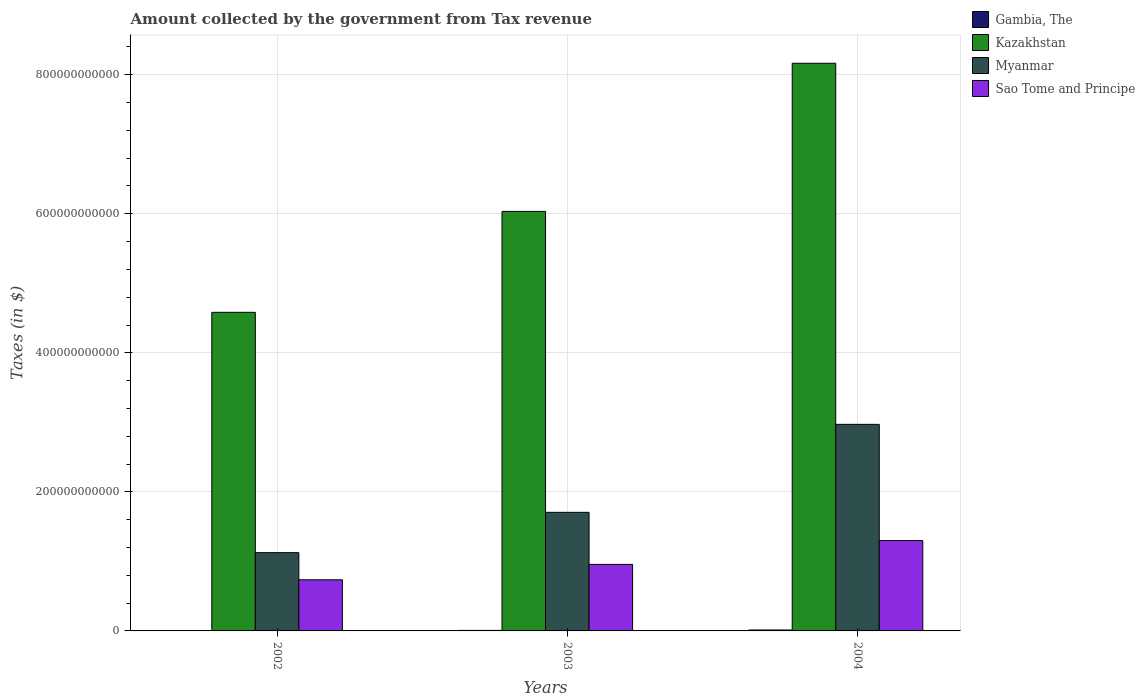How many different coloured bars are there?
Ensure brevity in your answer.  4. Are the number of bars per tick equal to the number of legend labels?
Provide a succinct answer. Yes. In how many cases, is the number of bars for a given year not equal to the number of legend labels?
Provide a short and direct response. 0. What is the amount collected by the government from tax revenue in Myanmar in 2003?
Make the answer very short. 1.71e+11. Across all years, what is the maximum amount collected by the government from tax revenue in Myanmar?
Keep it short and to the point. 2.97e+11. Across all years, what is the minimum amount collected by the government from tax revenue in Kazakhstan?
Make the answer very short. 4.58e+11. In which year was the amount collected by the government from tax revenue in Kazakhstan maximum?
Give a very brief answer. 2004. What is the total amount collected by the government from tax revenue in Gambia, The in the graph?
Your answer should be compact. 2.70e+09. What is the difference between the amount collected by the government from tax revenue in Kazakhstan in 2002 and that in 2003?
Your answer should be compact. -1.45e+11. What is the difference between the amount collected by the government from tax revenue in Kazakhstan in 2002 and the amount collected by the government from tax revenue in Gambia, The in 2004?
Keep it short and to the point. 4.57e+11. What is the average amount collected by the government from tax revenue in Sao Tome and Principe per year?
Your answer should be compact. 9.97e+1. In the year 2004, what is the difference between the amount collected by the government from tax revenue in Myanmar and amount collected by the government from tax revenue in Kazakhstan?
Your answer should be very brief. -5.19e+11. What is the ratio of the amount collected by the government from tax revenue in Gambia, The in 2002 to that in 2004?
Your answer should be compact. 0.41. Is the difference between the amount collected by the government from tax revenue in Myanmar in 2002 and 2003 greater than the difference between the amount collected by the government from tax revenue in Kazakhstan in 2002 and 2003?
Keep it short and to the point. Yes. What is the difference between the highest and the second highest amount collected by the government from tax revenue in Myanmar?
Your answer should be compact. 1.27e+11. What is the difference between the highest and the lowest amount collected by the government from tax revenue in Kazakhstan?
Offer a terse response. 3.58e+11. What does the 1st bar from the left in 2002 represents?
Your answer should be compact. Gambia, The. What does the 3rd bar from the right in 2002 represents?
Your answer should be compact. Kazakhstan. How many years are there in the graph?
Give a very brief answer. 3. What is the difference between two consecutive major ticks on the Y-axis?
Your response must be concise. 2.00e+11. Are the values on the major ticks of Y-axis written in scientific E-notation?
Ensure brevity in your answer.  No. Does the graph contain any zero values?
Give a very brief answer. No. How are the legend labels stacked?
Your response must be concise. Vertical. What is the title of the graph?
Offer a very short reply. Amount collected by the government from Tax revenue. What is the label or title of the Y-axis?
Make the answer very short. Taxes (in $). What is the Taxes (in $) of Gambia, The in 2002?
Keep it short and to the point. 5.61e+08. What is the Taxes (in $) in Kazakhstan in 2002?
Offer a terse response. 4.58e+11. What is the Taxes (in $) of Myanmar in 2002?
Offer a very short reply. 1.13e+11. What is the Taxes (in $) of Sao Tome and Principe in 2002?
Ensure brevity in your answer.  7.35e+1. What is the Taxes (in $) in Gambia, The in 2003?
Give a very brief answer. 7.76e+08. What is the Taxes (in $) of Kazakhstan in 2003?
Provide a short and direct response. 6.03e+11. What is the Taxes (in $) in Myanmar in 2003?
Provide a short and direct response. 1.71e+11. What is the Taxes (in $) in Sao Tome and Principe in 2003?
Offer a very short reply. 9.57e+1. What is the Taxes (in $) in Gambia, The in 2004?
Offer a terse response. 1.36e+09. What is the Taxes (in $) in Kazakhstan in 2004?
Your answer should be very brief. 8.16e+11. What is the Taxes (in $) of Myanmar in 2004?
Keep it short and to the point. 2.97e+11. What is the Taxes (in $) of Sao Tome and Principe in 2004?
Provide a succinct answer. 1.30e+11. Across all years, what is the maximum Taxes (in $) of Gambia, The?
Make the answer very short. 1.36e+09. Across all years, what is the maximum Taxes (in $) of Kazakhstan?
Give a very brief answer. 8.16e+11. Across all years, what is the maximum Taxes (in $) in Myanmar?
Your answer should be compact. 2.97e+11. Across all years, what is the maximum Taxes (in $) in Sao Tome and Principe?
Your answer should be compact. 1.30e+11. Across all years, what is the minimum Taxes (in $) in Gambia, The?
Provide a short and direct response. 5.61e+08. Across all years, what is the minimum Taxes (in $) of Kazakhstan?
Provide a succinct answer. 4.58e+11. Across all years, what is the minimum Taxes (in $) in Myanmar?
Your answer should be very brief. 1.13e+11. Across all years, what is the minimum Taxes (in $) of Sao Tome and Principe?
Provide a short and direct response. 7.35e+1. What is the total Taxes (in $) in Gambia, The in the graph?
Your answer should be compact. 2.70e+09. What is the total Taxes (in $) of Kazakhstan in the graph?
Keep it short and to the point. 1.88e+12. What is the total Taxes (in $) in Myanmar in the graph?
Your answer should be compact. 5.80e+11. What is the total Taxes (in $) of Sao Tome and Principe in the graph?
Offer a terse response. 2.99e+11. What is the difference between the Taxes (in $) in Gambia, The in 2002 and that in 2003?
Give a very brief answer. -2.15e+08. What is the difference between the Taxes (in $) in Kazakhstan in 2002 and that in 2003?
Provide a succinct answer. -1.45e+11. What is the difference between the Taxes (in $) of Myanmar in 2002 and that in 2003?
Give a very brief answer. -5.80e+1. What is the difference between the Taxes (in $) of Sao Tome and Principe in 2002 and that in 2003?
Offer a terse response. -2.21e+1. What is the difference between the Taxes (in $) in Gambia, The in 2002 and that in 2004?
Ensure brevity in your answer.  -8.04e+08. What is the difference between the Taxes (in $) in Kazakhstan in 2002 and that in 2004?
Your response must be concise. -3.58e+11. What is the difference between the Taxes (in $) in Myanmar in 2002 and that in 2004?
Provide a succinct answer. -1.85e+11. What is the difference between the Taxes (in $) of Sao Tome and Principe in 2002 and that in 2004?
Provide a short and direct response. -5.64e+1. What is the difference between the Taxes (in $) in Gambia, The in 2003 and that in 2004?
Give a very brief answer. -5.88e+08. What is the difference between the Taxes (in $) of Kazakhstan in 2003 and that in 2004?
Ensure brevity in your answer.  -2.13e+11. What is the difference between the Taxes (in $) of Myanmar in 2003 and that in 2004?
Your answer should be very brief. -1.27e+11. What is the difference between the Taxes (in $) in Sao Tome and Principe in 2003 and that in 2004?
Offer a terse response. -3.42e+1. What is the difference between the Taxes (in $) in Gambia, The in 2002 and the Taxes (in $) in Kazakhstan in 2003?
Offer a terse response. -6.03e+11. What is the difference between the Taxes (in $) in Gambia, The in 2002 and the Taxes (in $) in Myanmar in 2003?
Keep it short and to the point. -1.70e+11. What is the difference between the Taxes (in $) in Gambia, The in 2002 and the Taxes (in $) in Sao Tome and Principe in 2003?
Make the answer very short. -9.51e+1. What is the difference between the Taxes (in $) of Kazakhstan in 2002 and the Taxes (in $) of Myanmar in 2003?
Offer a very short reply. 2.88e+11. What is the difference between the Taxes (in $) in Kazakhstan in 2002 and the Taxes (in $) in Sao Tome and Principe in 2003?
Your answer should be compact. 3.63e+11. What is the difference between the Taxes (in $) in Myanmar in 2002 and the Taxes (in $) in Sao Tome and Principe in 2003?
Your answer should be compact. 1.69e+1. What is the difference between the Taxes (in $) in Gambia, The in 2002 and the Taxes (in $) in Kazakhstan in 2004?
Give a very brief answer. -8.16e+11. What is the difference between the Taxes (in $) of Gambia, The in 2002 and the Taxes (in $) of Myanmar in 2004?
Offer a terse response. -2.97e+11. What is the difference between the Taxes (in $) of Gambia, The in 2002 and the Taxes (in $) of Sao Tome and Principe in 2004?
Make the answer very short. -1.29e+11. What is the difference between the Taxes (in $) of Kazakhstan in 2002 and the Taxes (in $) of Myanmar in 2004?
Your answer should be very brief. 1.61e+11. What is the difference between the Taxes (in $) in Kazakhstan in 2002 and the Taxes (in $) in Sao Tome and Principe in 2004?
Provide a short and direct response. 3.28e+11. What is the difference between the Taxes (in $) of Myanmar in 2002 and the Taxes (in $) of Sao Tome and Principe in 2004?
Keep it short and to the point. -1.74e+1. What is the difference between the Taxes (in $) of Gambia, The in 2003 and the Taxes (in $) of Kazakhstan in 2004?
Make the answer very short. -8.16e+11. What is the difference between the Taxes (in $) in Gambia, The in 2003 and the Taxes (in $) in Myanmar in 2004?
Provide a succinct answer. -2.96e+11. What is the difference between the Taxes (in $) in Gambia, The in 2003 and the Taxes (in $) in Sao Tome and Principe in 2004?
Offer a terse response. -1.29e+11. What is the difference between the Taxes (in $) in Kazakhstan in 2003 and the Taxes (in $) in Myanmar in 2004?
Provide a short and direct response. 3.06e+11. What is the difference between the Taxes (in $) in Kazakhstan in 2003 and the Taxes (in $) in Sao Tome and Principe in 2004?
Provide a succinct answer. 4.73e+11. What is the difference between the Taxes (in $) in Myanmar in 2003 and the Taxes (in $) in Sao Tome and Principe in 2004?
Provide a short and direct response. 4.06e+1. What is the average Taxes (in $) in Gambia, The per year?
Make the answer very short. 9.00e+08. What is the average Taxes (in $) in Kazakhstan per year?
Offer a terse response. 6.26e+11. What is the average Taxes (in $) of Myanmar per year?
Make the answer very short. 1.93e+11. What is the average Taxes (in $) in Sao Tome and Principe per year?
Make the answer very short. 9.97e+1. In the year 2002, what is the difference between the Taxes (in $) of Gambia, The and Taxes (in $) of Kazakhstan?
Your answer should be very brief. -4.58e+11. In the year 2002, what is the difference between the Taxes (in $) of Gambia, The and Taxes (in $) of Myanmar?
Provide a short and direct response. -1.12e+11. In the year 2002, what is the difference between the Taxes (in $) of Gambia, The and Taxes (in $) of Sao Tome and Principe?
Give a very brief answer. -7.30e+1. In the year 2002, what is the difference between the Taxes (in $) of Kazakhstan and Taxes (in $) of Myanmar?
Your answer should be very brief. 3.46e+11. In the year 2002, what is the difference between the Taxes (in $) in Kazakhstan and Taxes (in $) in Sao Tome and Principe?
Give a very brief answer. 3.85e+11. In the year 2002, what is the difference between the Taxes (in $) in Myanmar and Taxes (in $) in Sao Tome and Principe?
Keep it short and to the point. 3.90e+1. In the year 2003, what is the difference between the Taxes (in $) of Gambia, The and Taxes (in $) of Kazakhstan?
Offer a terse response. -6.03e+11. In the year 2003, what is the difference between the Taxes (in $) of Gambia, The and Taxes (in $) of Myanmar?
Ensure brevity in your answer.  -1.70e+11. In the year 2003, what is the difference between the Taxes (in $) of Gambia, The and Taxes (in $) of Sao Tome and Principe?
Keep it short and to the point. -9.49e+1. In the year 2003, what is the difference between the Taxes (in $) of Kazakhstan and Taxes (in $) of Myanmar?
Provide a short and direct response. 4.33e+11. In the year 2003, what is the difference between the Taxes (in $) of Kazakhstan and Taxes (in $) of Sao Tome and Principe?
Your answer should be very brief. 5.08e+11. In the year 2003, what is the difference between the Taxes (in $) in Myanmar and Taxes (in $) in Sao Tome and Principe?
Make the answer very short. 7.49e+1. In the year 2004, what is the difference between the Taxes (in $) of Gambia, The and Taxes (in $) of Kazakhstan?
Offer a terse response. -8.15e+11. In the year 2004, what is the difference between the Taxes (in $) of Gambia, The and Taxes (in $) of Myanmar?
Ensure brevity in your answer.  -2.96e+11. In the year 2004, what is the difference between the Taxes (in $) in Gambia, The and Taxes (in $) in Sao Tome and Principe?
Keep it short and to the point. -1.29e+11. In the year 2004, what is the difference between the Taxes (in $) of Kazakhstan and Taxes (in $) of Myanmar?
Offer a very short reply. 5.19e+11. In the year 2004, what is the difference between the Taxes (in $) of Kazakhstan and Taxes (in $) of Sao Tome and Principe?
Offer a very short reply. 6.87e+11. In the year 2004, what is the difference between the Taxes (in $) in Myanmar and Taxes (in $) in Sao Tome and Principe?
Offer a very short reply. 1.67e+11. What is the ratio of the Taxes (in $) of Gambia, The in 2002 to that in 2003?
Your answer should be very brief. 0.72. What is the ratio of the Taxes (in $) in Kazakhstan in 2002 to that in 2003?
Give a very brief answer. 0.76. What is the ratio of the Taxes (in $) in Myanmar in 2002 to that in 2003?
Your answer should be very brief. 0.66. What is the ratio of the Taxes (in $) of Sao Tome and Principe in 2002 to that in 2003?
Your answer should be compact. 0.77. What is the ratio of the Taxes (in $) in Gambia, The in 2002 to that in 2004?
Offer a terse response. 0.41. What is the ratio of the Taxes (in $) in Kazakhstan in 2002 to that in 2004?
Make the answer very short. 0.56. What is the ratio of the Taxes (in $) of Myanmar in 2002 to that in 2004?
Your answer should be compact. 0.38. What is the ratio of the Taxes (in $) in Sao Tome and Principe in 2002 to that in 2004?
Keep it short and to the point. 0.57. What is the ratio of the Taxes (in $) of Gambia, The in 2003 to that in 2004?
Offer a terse response. 0.57. What is the ratio of the Taxes (in $) of Kazakhstan in 2003 to that in 2004?
Provide a succinct answer. 0.74. What is the ratio of the Taxes (in $) of Myanmar in 2003 to that in 2004?
Your answer should be compact. 0.57. What is the ratio of the Taxes (in $) in Sao Tome and Principe in 2003 to that in 2004?
Your answer should be very brief. 0.74. What is the difference between the highest and the second highest Taxes (in $) of Gambia, The?
Ensure brevity in your answer.  5.88e+08. What is the difference between the highest and the second highest Taxes (in $) in Kazakhstan?
Your answer should be compact. 2.13e+11. What is the difference between the highest and the second highest Taxes (in $) in Myanmar?
Make the answer very short. 1.27e+11. What is the difference between the highest and the second highest Taxes (in $) of Sao Tome and Principe?
Provide a succinct answer. 3.42e+1. What is the difference between the highest and the lowest Taxes (in $) in Gambia, The?
Keep it short and to the point. 8.04e+08. What is the difference between the highest and the lowest Taxes (in $) of Kazakhstan?
Provide a short and direct response. 3.58e+11. What is the difference between the highest and the lowest Taxes (in $) of Myanmar?
Ensure brevity in your answer.  1.85e+11. What is the difference between the highest and the lowest Taxes (in $) in Sao Tome and Principe?
Provide a succinct answer. 5.64e+1. 